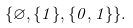<formula> <loc_0><loc_0><loc_500><loc_500>\{ \varnothing , \{ 1 \} , \{ 0 , 1 \} \} .</formula> 